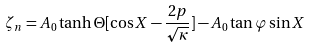Convert formula to latex. <formula><loc_0><loc_0><loc_500><loc_500>\zeta _ { n } = A _ { 0 } \tanh \Theta [ \cos X - \frac { 2 p } { \sqrt { \kappa } } ] - A _ { 0 } \tan \varphi \sin X</formula> 